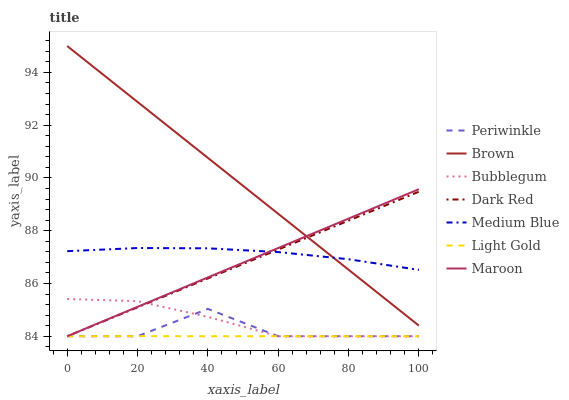Does Light Gold have the minimum area under the curve?
Answer yes or no. Yes. Does Brown have the maximum area under the curve?
Answer yes or no. Yes. Does Dark Red have the minimum area under the curve?
Answer yes or no. No. Does Dark Red have the maximum area under the curve?
Answer yes or no. No. Is Maroon the smoothest?
Answer yes or no. Yes. Is Periwinkle the roughest?
Answer yes or no. Yes. Is Dark Red the smoothest?
Answer yes or no. No. Is Dark Red the roughest?
Answer yes or no. No. Does Dark Red have the lowest value?
Answer yes or no. Yes. Does Medium Blue have the lowest value?
Answer yes or no. No. Does Brown have the highest value?
Answer yes or no. Yes. Does Dark Red have the highest value?
Answer yes or no. No. Is Bubblegum less than Brown?
Answer yes or no. Yes. Is Medium Blue greater than Light Gold?
Answer yes or no. Yes. Does Maroon intersect Periwinkle?
Answer yes or no. Yes. Is Maroon less than Periwinkle?
Answer yes or no. No. Is Maroon greater than Periwinkle?
Answer yes or no. No. Does Bubblegum intersect Brown?
Answer yes or no. No. 